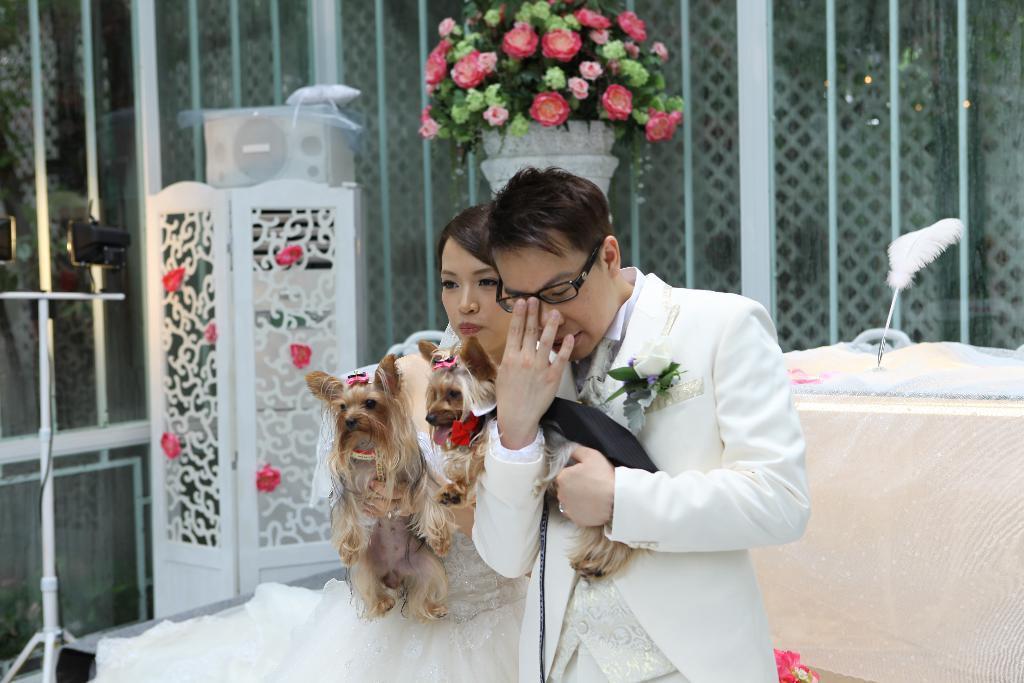Can you describe this image briefly? In this picture we can see a man and woman, the woman holding dogs in her hands. In the background we can see some flowers and lights. 